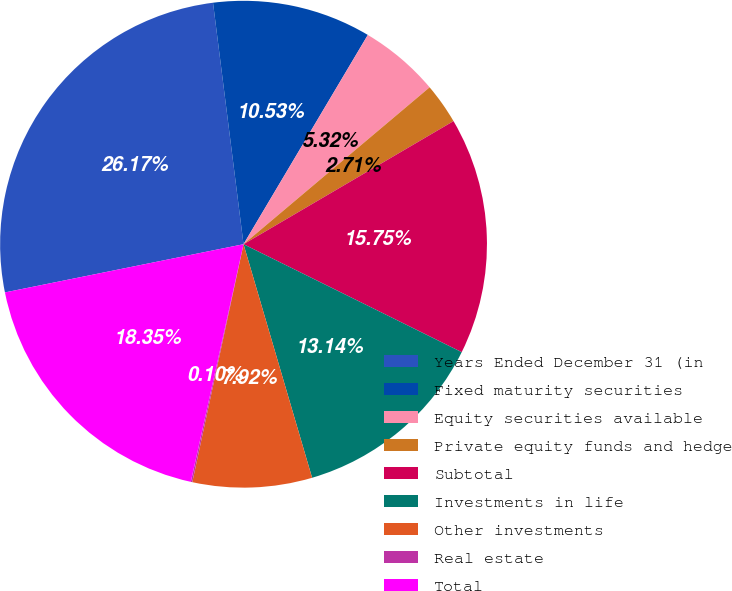<chart> <loc_0><loc_0><loc_500><loc_500><pie_chart><fcel>Years Ended December 31 (in<fcel>Fixed maturity securities<fcel>Equity securities available<fcel>Private equity funds and hedge<fcel>Subtotal<fcel>Investments in life<fcel>Other investments<fcel>Real estate<fcel>Total<nl><fcel>26.17%<fcel>10.53%<fcel>5.32%<fcel>2.71%<fcel>15.75%<fcel>13.14%<fcel>7.92%<fcel>0.1%<fcel>18.35%<nl></chart> 